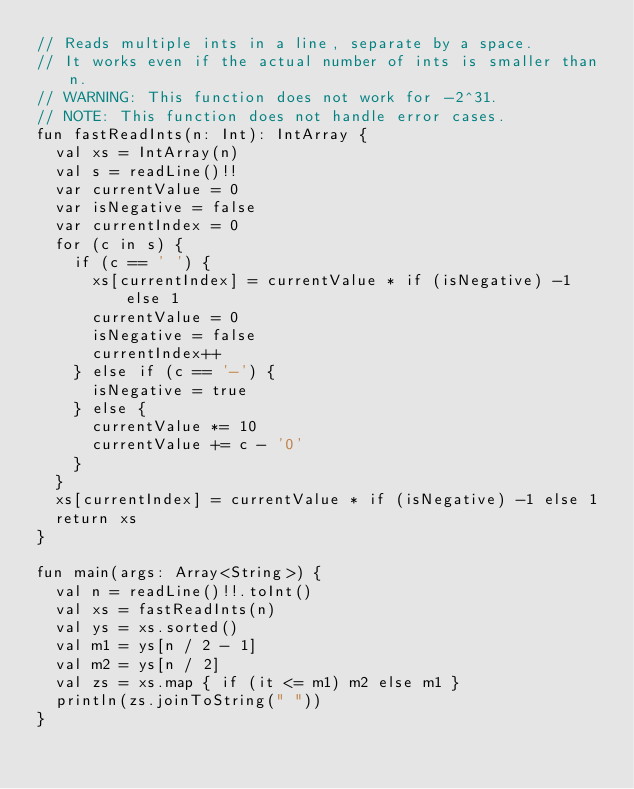Convert code to text. <code><loc_0><loc_0><loc_500><loc_500><_Kotlin_>// Reads multiple ints in a line, separate by a space.
// It works even if the actual number of ints is smaller than n.
// WARNING: This function does not work for -2^31.
// NOTE: This function does not handle error cases.
fun fastReadInts(n: Int): IntArray {
  val xs = IntArray(n)
  val s = readLine()!!
  var currentValue = 0
  var isNegative = false
  var currentIndex = 0
  for (c in s) {
    if (c == ' ') {
      xs[currentIndex] = currentValue * if (isNegative) -1 else 1
      currentValue = 0
      isNegative = false
      currentIndex++
    } else if (c == '-') {
      isNegative = true
    } else {
      currentValue *= 10
      currentValue += c - '0'
    }
  }
  xs[currentIndex] = currentValue * if (isNegative) -1 else 1
  return xs
}

fun main(args: Array<String>) {
  val n = readLine()!!.toInt()
  val xs = fastReadInts(n)
  val ys = xs.sorted()
  val m1 = ys[n / 2 - 1]
  val m2 = ys[n / 2]
  val zs = xs.map { if (it <= m1) m2 else m1 }
  println(zs.joinToString(" "))
}
</code> 